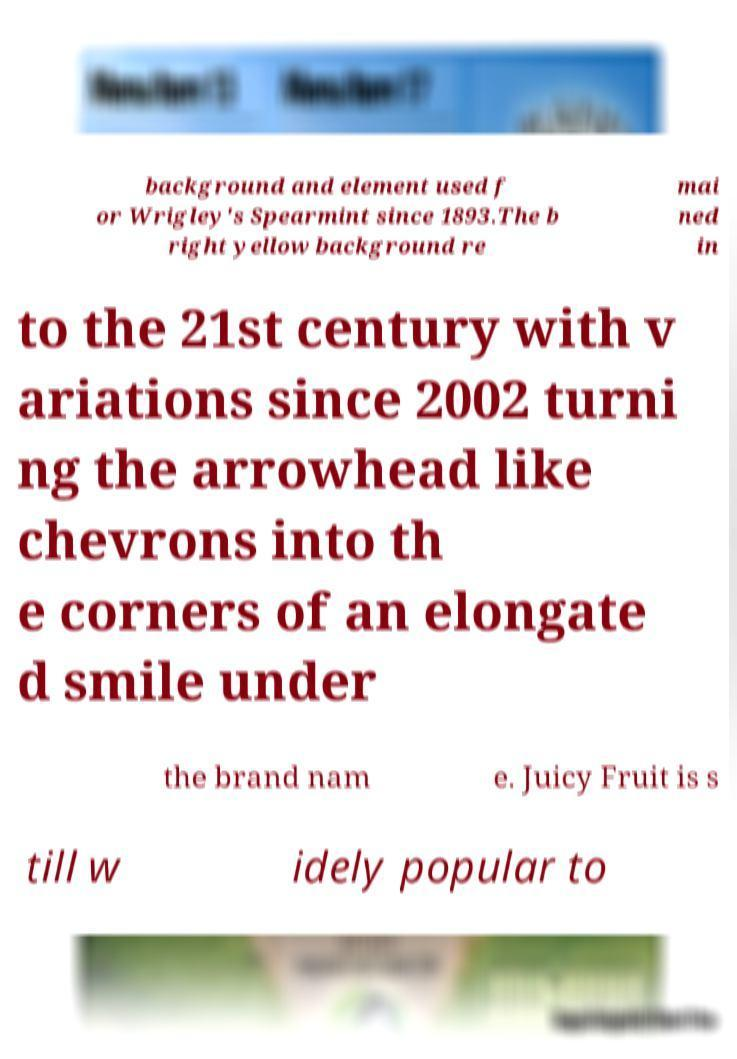Could you assist in decoding the text presented in this image and type it out clearly? background and element used f or Wrigley's Spearmint since 1893.The b right yellow background re mai ned in to the 21st century with v ariations since 2002 turni ng the arrowhead like chevrons into th e corners of an elongate d smile under the brand nam e. Juicy Fruit is s till w idely popular to 